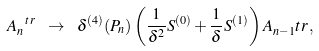Convert formula to latex. <formula><loc_0><loc_0><loc_500><loc_500>\ A _ { n } ^ { \ t r } \ \to \ \delta ^ { ( 4 ) } ( P _ { n } ) \left ( \frac { 1 } { \delta ^ { 2 } } S ^ { ( 0 ) } + \frac { 1 } { \delta } S ^ { ( 1 ) } \right ) A _ { n - 1 } ^ { \ } t r \, ,</formula> 